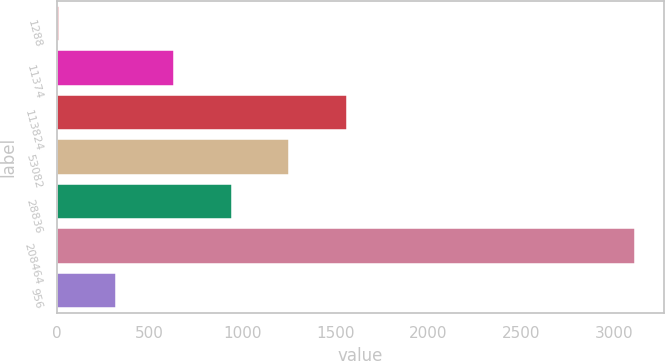Convert chart. <chart><loc_0><loc_0><loc_500><loc_500><bar_chart><fcel>1288<fcel>11374<fcel>113824<fcel>53082<fcel>28836<fcel>208464<fcel>956<nl><fcel>12.3<fcel>632.84<fcel>1563.65<fcel>1253.38<fcel>943.11<fcel>3115<fcel>322.57<nl></chart> 